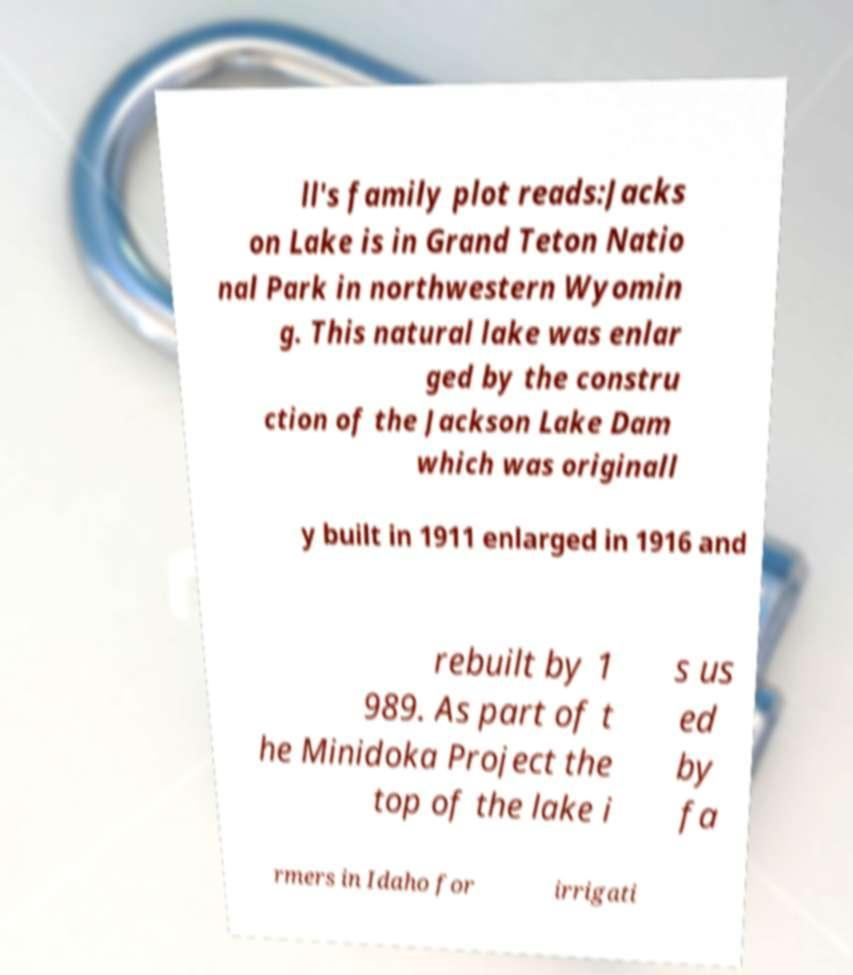Can you accurately transcribe the text from the provided image for me? ll's family plot reads:Jacks on Lake is in Grand Teton Natio nal Park in northwestern Wyomin g. This natural lake was enlar ged by the constru ction of the Jackson Lake Dam which was originall y built in 1911 enlarged in 1916 and rebuilt by 1 989. As part of t he Minidoka Project the top of the lake i s us ed by fa rmers in Idaho for irrigati 